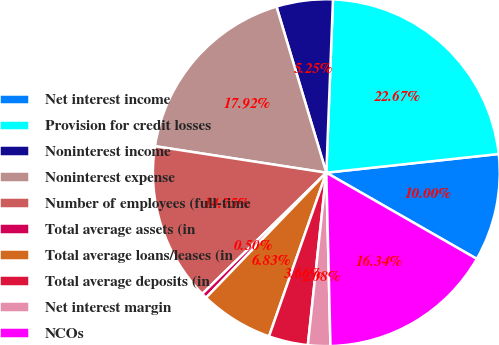Convert chart. <chart><loc_0><loc_0><loc_500><loc_500><pie_chart><fcel>Net interest income<fcel>Provision for credit losses<fcel>Noninterest income<fcel>Noninterest expense<fcel>Number of employees (full-time<fcel>Total average assets (in<fcel>Total average loans/leases (in<fcel>Total average deposits (in<fcel>Net interest margin<fcel>NCOs<nl><fcel>10.0%<fcel>22.67%<fcel>5.25%<fcel>17.92%<fcel>14.75%<fcel>0.5%<fcel>6.83%<fcel>3.66%<fcel>2.08%<fcel>16.34%<nl></chart> 